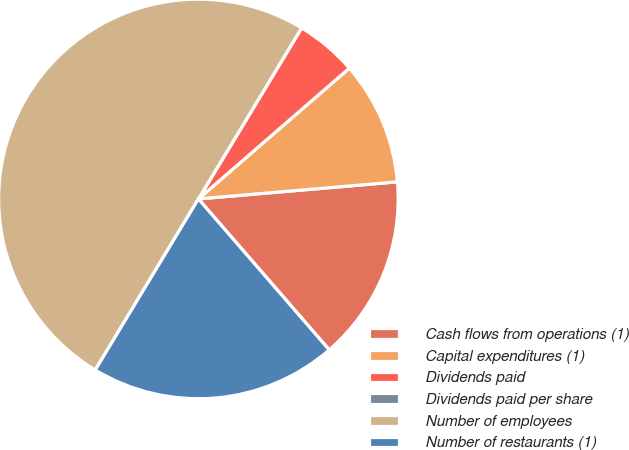Convert chart to OTSL. <chart><loc_0><loc_0><loc_500><loc_500><pie_chart><fcel>Cash flows from operations (1)<fcel>Capital expenditures (1)<fcel>Dividends paid<fcel>Dividends paid per share<fcel>Number of employees<fcel>Number of restaurants (1)<nl><fcel>15.0%<fcel>10.0%<fcel>5.0%<fcel>0.0%<fcel>50.0%<fcel>20.0%<nl></chart> 